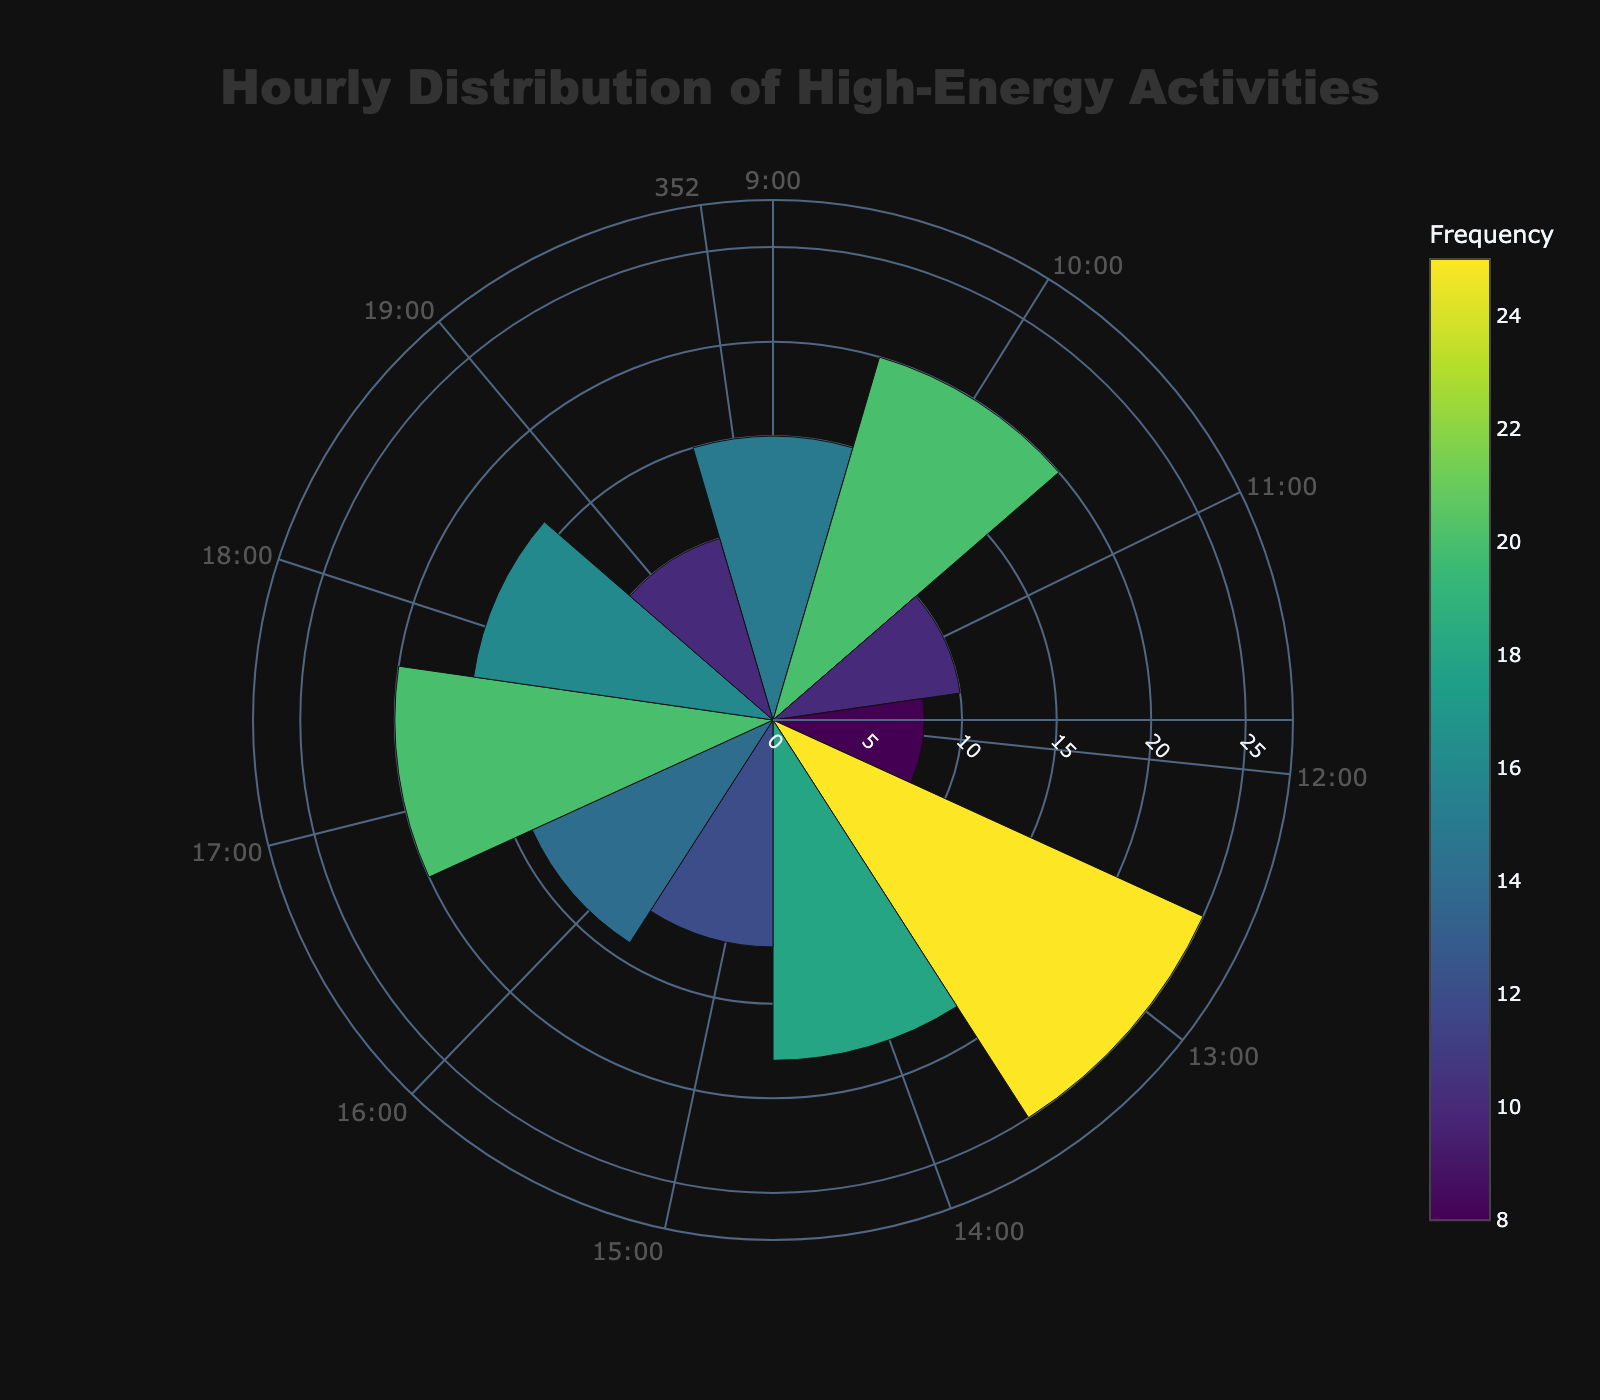Which activity has the highest frequency? The activity with the highest frequency can be identified by looking for the largest bar in the rose chart.
Answer: Snowball Fight Tournament What's the title of the figure? The title is usually displayed at the top of the figure.
Answer: Hourly Distribution of High-Energy Activities How many activities have a frequency greater than 15? Count the number of bars with a height (radius) greater than 15.
Answer: Five What is the total frequency of activities from 15:00 to 17:00? Identify the bars corresponding to 15:00, 16:00, and 17:00. Sum their frequencies (12 + 14 + 20).
Answer: 46 Which hour has the lowest activity frequency? Find the bar with the smallest radius.
Answer: 12:00 How does the frequency of the Freestyle Skiing event compare to the Speed Skating Challenge? Find the bar for Freestyle Skiing and Speed Skating Challenge, then compare their frequencies.
Answer: Freestyle Skiing has a higher frequency than Speed Skating Challenge What is the average frequency of all activities? Sum the frequencies of all activities (178) and divide by the number of activities (11).
Answer: 16.18 Which activity is held at 10:00? Locate the bar corresponding to 10:00 and read the activity name.
Answer: Ice Sculpting Competition What is the range of frequencies shown in the chart? Subtract the smallest frequency value from the largest frequency value (25 - 8).
Answer: 17 